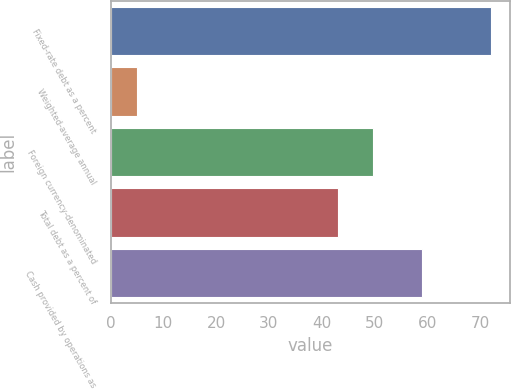<chart> <loc_0><loc_0><loc_500><loc_500><bar_chart><fcel>Fixed-rate debt as a percent<fcel>Weighted-average annual<fcel>Foreign currency-denominated<fcel>Total debt as a percent of<fcel>Cash provided by operations as<nl><fcel>72<fcel>5<fcel>49.7<fcel>43<fcel>59<nl></chart> 